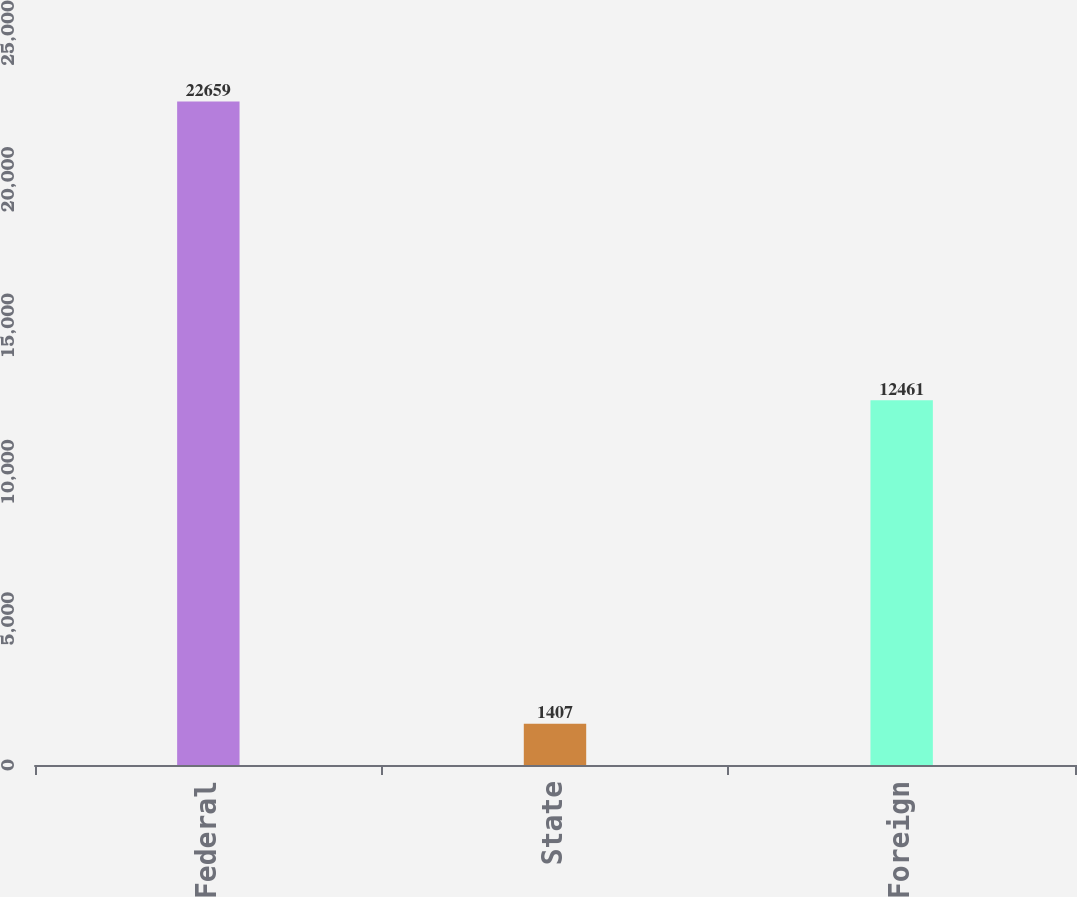Convert chart to OTSL. <chart><loc_0><loc_0><loc_500><loc_500><bar_chart><fcel>Federal<fcel>State<fcel>Foreign<nl><fcel>22659<fcel>1407<fcel>12461<nl></chart> 